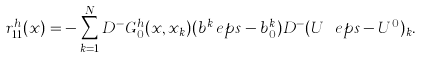<formula> <loc_0><loc_0><loc_500><loc_500>r ^ { h } _ { 1 1 } ( x ) = - \sum _ { k = 1 } ^ { N } D ^ { - } G ^ { h } _ { 0 } ( x , x _ { k } ) ( b ^ { k } _ { \ } e p s - b ^ { k } _ { 0 } ) D ^ { - } ( U ^ { \ } e p s - U ^ { 0 } ) _ { k } .</formula> 